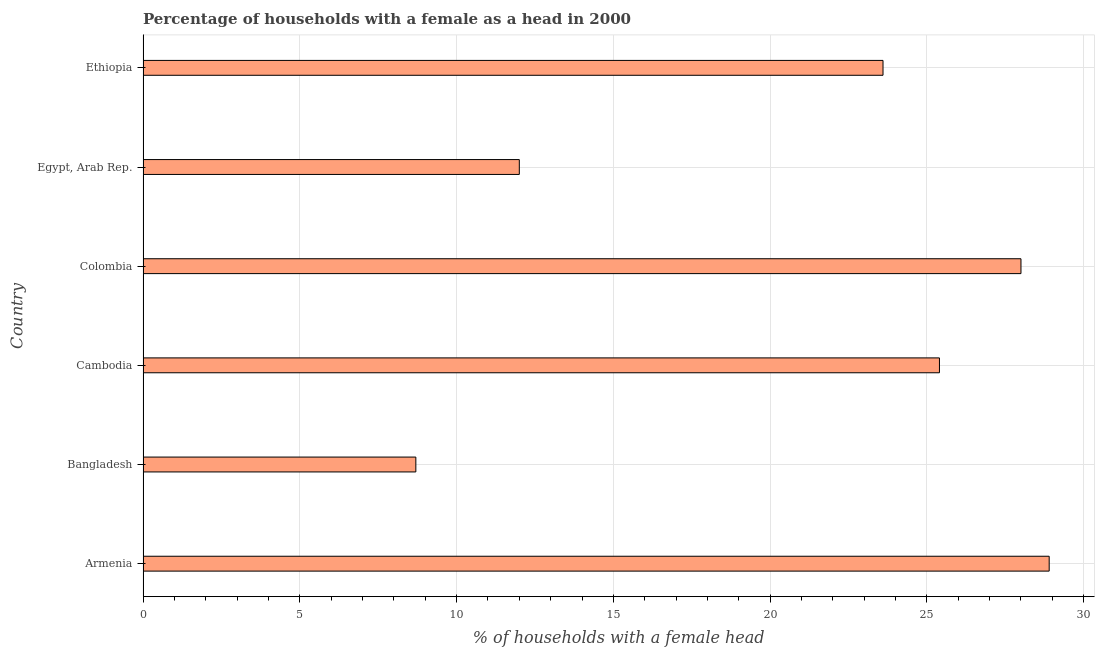Does the graph contain grids?
Offer a very short reply. Yes. What is the title of the graph?
Offer a very short reply. Percentage of households with a female as a head in 2000. What is the label or title of the X-axis?
Give a very brief answer. % of households with a female head. What is the label or title of the Y-axis?
Offer a terse response. Country. What is the number of female supervised households in Armenia?
Make the answer very short. 28.9. Across all countries, what is the maximum number of female supervised households?
Give a very brief answer. 28.9. Across all countries, what is the minimum number of female supervised households?
Your response must be concise. 8.7. In which country was the number of female supervised households maximum?
Provide a short and direct response. Armenia. In which country was the number of female supervised households minimum?
Your answer should be compact. Bangladesh. What is the sum of the number of female supervised households?
Your answer should be very brief. 126.6. What is the difference between the number of female supervised households in Armenia and Egypt, Arab Rep.?
Make the answer very short. 16.9. What is the average number of female supervised households per country?
Ensure brevity in your answer.  21.1. What is the ratio of the number of female supervised households in Cambodia to that in Ethiopia?
Offer a very short reply. 1.08. Is the number of female supervised households in Armenia less than that in Cambodia?
Provide a short and direct response. No. What is the difference between the highest and the lowest number of female supervised households?
Keep it short and to the point. 20.2. How many bars are there?
Make the answer very short. 6. Are all the bars in the graph horizontal?
Keep it short and to the point. Yes. How many countries are there in the graph?
Ensure brevity in your answer.  6. Are the values on the major ticks of X-axis written in scientific E-notation?
Make the answer very short. No. What is the % of households with a female head of Armenia?
Offer a very short reply. 28.9. What is the % of households with a female head of Cambodia?
Keep it short and to the point. 25.4. What is the % of households with a female head in Egypt, Arab Rep.?
Give a very brief answer. 12. What is the % of households with a female head in Ethiopia?
Your response must be concise. 23.6. What is the difference between the % of households with a female head in Armenia and Bangladesh?
Offer a very short reply. 20.2. What is the difference between the % of households with a female head in Armenia and Colombia?
Offer a very short reply. 0.9. What is the difference between the % of households with a female head in Bangladesh and Cambodia?
Make the answer very short. -16.7. What is the difference between the % of households with a female head in Bangladesh and Colombia?
Give a very brief answer. -19.3. What is the difference between the % of households with a female head in Bangladesh and Egypt, Arab Rep.?
Offer a terse response. -3.3. What is the difference between the % of households with a female head in Bangladesh and Ethiopia?
Offer a terse response. -14.9. What is the difference between the % of households with a female head in Cambodia and Colombia?
Your answer should be very brief. -2.6. What is the difference between the % of households with a female head in Egypt, Arab Rep. and Ethiopia?
Provide a succinct answer. -11.6. What is the ratio of the % of households with a female head in Armenia to that in Bangladesh?
Give a very brief answer. 3.32. What is the ratio of the % of households with a female head in Armenia to that in Cambodia?
Your answer should be very brief. 1.14. What is the ratio of the % of households with a female head in Armenia to that in Colombia?
Make the answer very short. 1.03. What is the ratio of the % of households with a female head in Armenia to that in Egypt, Arab Rep.?
Offer a very short reply. 2.41. What is the ratio of the % of households with a female head in Armenia to that in Ethiopia?
Offer a terse response. 1.23. What is the ratio of the % of households with a female head in Bangladesh to that in Cambodia?
Keep it short and to the point. 0.34. What is the ratio of the % of households with a female head in Bangladesh to that in Colombia?
Make the answer very short. 0.31. What is the ratio of the % of households with a female head in Bangladesh to that in Egypt, Arab Rep.?
Give a very brief answer. 0.72. What is the ratio of the % of households with a female head in Bangladesh to that in Ethiopia?
Offer a terse response. 0.37. What is the ratio of the % of households with a female head in Cambodia to that in Colombia?
Provide a succinct answer. 0.91. What is the ratio of the % of households with a female head in Cambodia to that in Egypt, Arab Rep.?
Your response must be concise. 2.12. What is the ratio of the % of households with a female head in Cambodia to that in Ethiopia?
Give a very brief answer. 1.08. What is the ratio of the % of households with a female head in Colombia to that in Egypt, Arab Rep.?
Your response must be concise. 2.33. What is the ratio of the % of households with a female head in Colombia to that in Ethiopia?
Offer a terse response. 1.19. What is the ratio of the % of households with a female head in Egypt, Arab Rep. to that in Ethiopia?
Offer a very short reply. 0.51. 